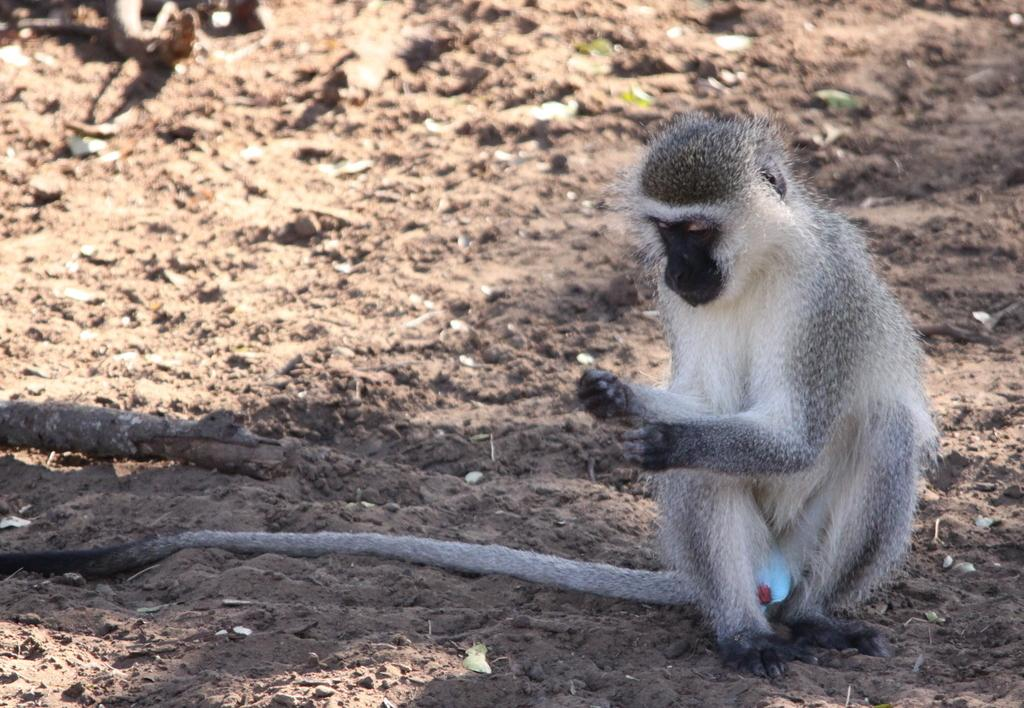What type of animal is in the image? There is a monkey in the image. What material are the poles made of in the image? The wooden poles are visible in the image. What type of terrain is at the bottom of the image? There is sand visible at the bottom of the image. What type of pies can be seen in the image? There are no pies present in the image; it features a monkey and wooden poles in a sandy environment. 